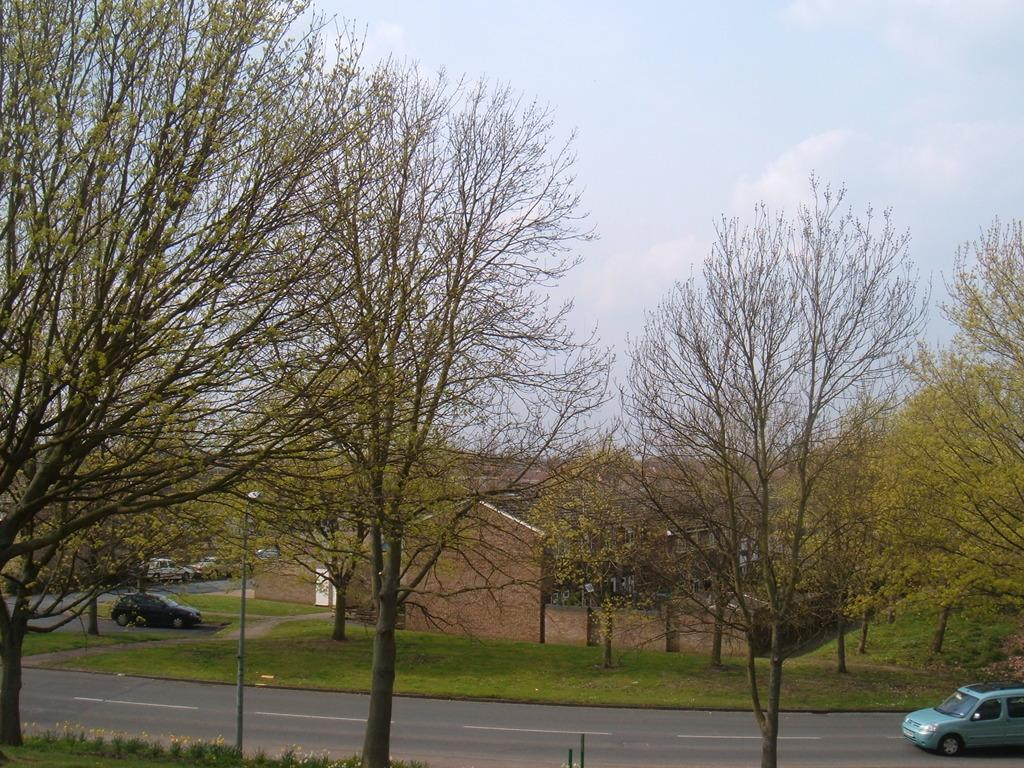What can be seen on the road in the image? There are vehicles on the road in the image. What type of structure is present in the image? There is a building in the image. What type of vegetation is visible in the image? There are trees in the image. What is visible in the background of the image? The sky is visible in the background of the image. What type of advice can be seen written on the building in the image? There is no advice written on the building in the image; it is a structure and not a source of advice. 